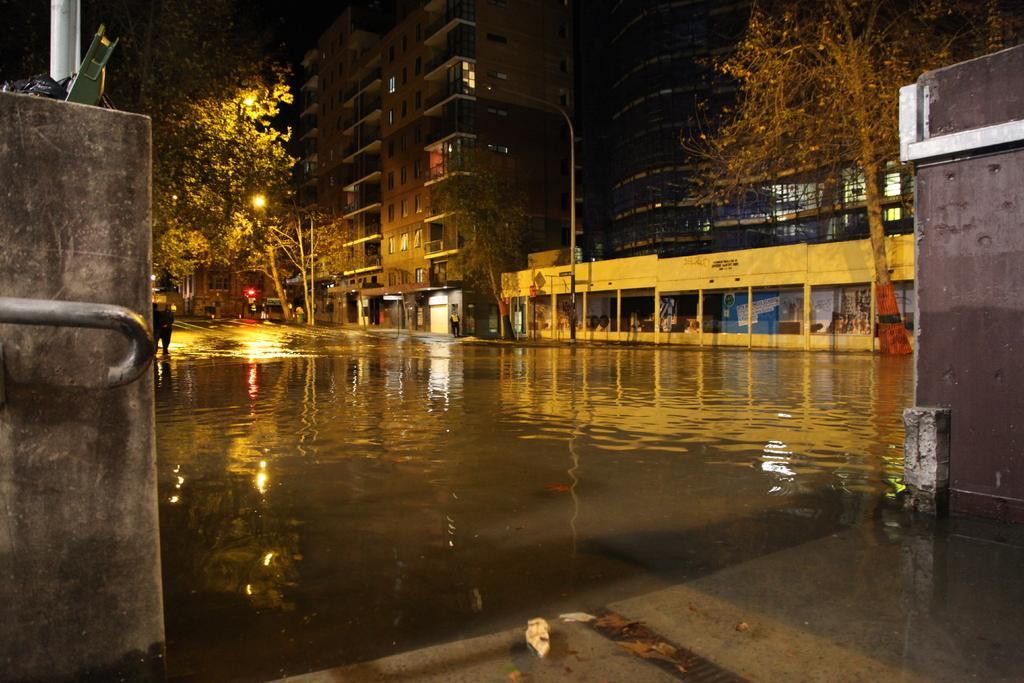Describe this image in one or two sentences. On the left side, there is a wall which is having a handler and a pole on the top. On the right side, there is another wall near water on the road. In the background, there are buildings which are having glass windows and lights, there are lights attached to the poles, there are trees and there are persons. 